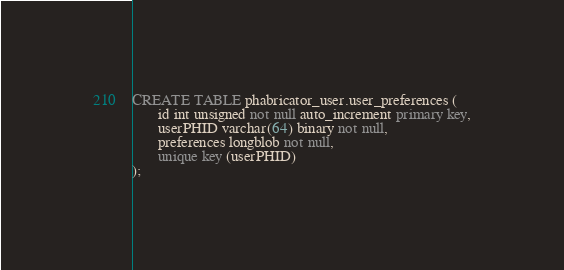Convert code to text. <code><loc_0><loc_0><loc_500><loc_500><_SQL_>CREATE TABLE phabricator_user.user_preferences (
       id int unsigned not null auto_increment primary key,
       userPHID varchar(64) binary not null,
       preferences longblob not null,
       unique key (userPHID)
);
</code> 